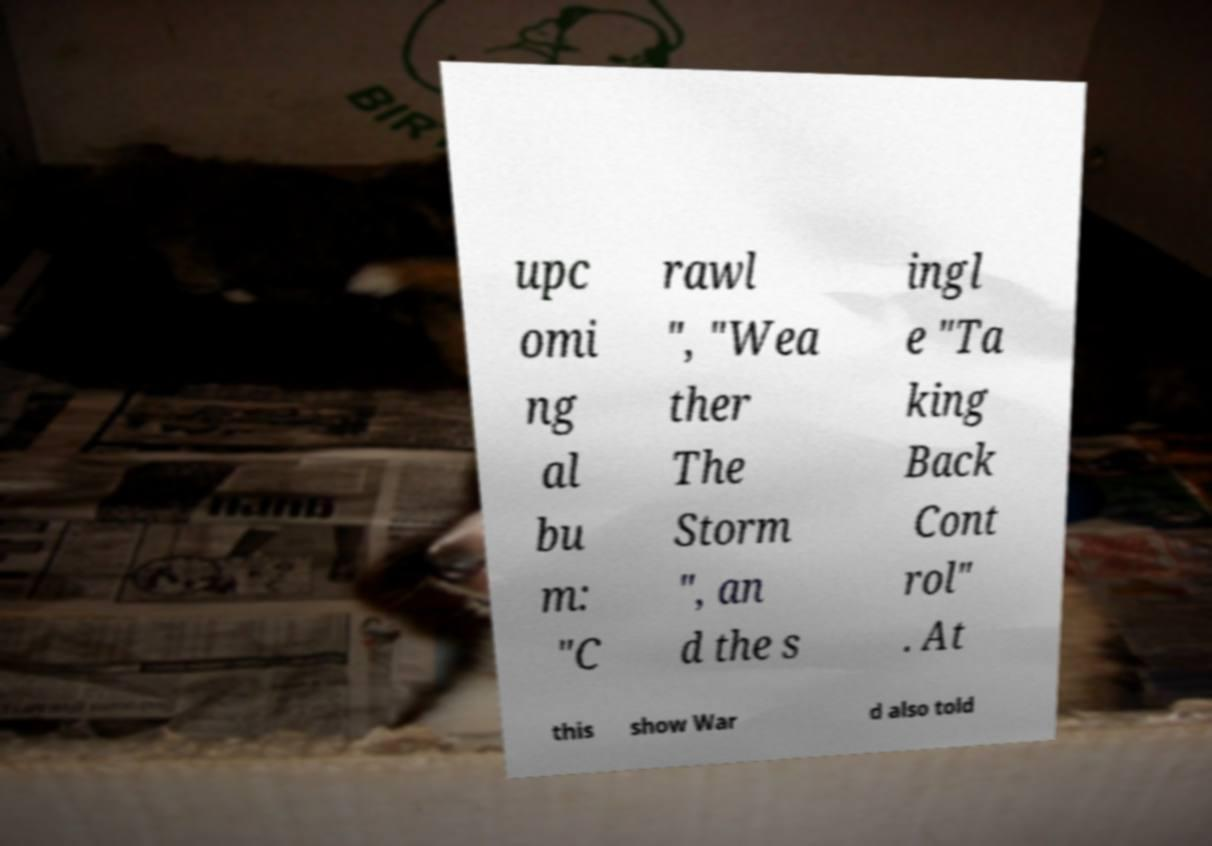Can you accurately transcribe the text from the provided image for me? upc omi ng al bu m: "C rawl ", "Wea ther The Storm ", an d the s ingl e "Ta king Back Cont rol" . At this show War d also told 